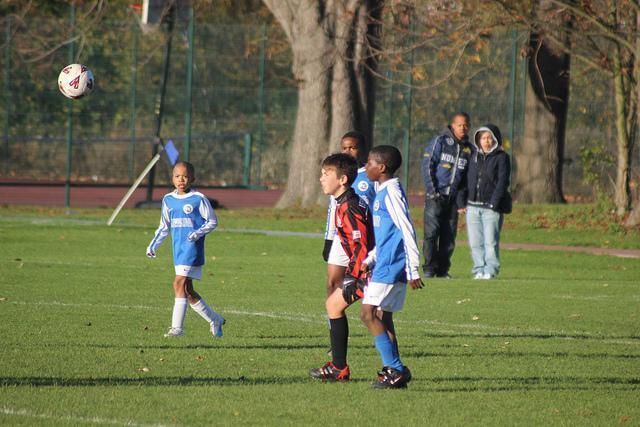How many people are playing?
Give a very brief answer. 4. How many children wear blue and white uniforms?
Give a very brief answer. 3. How many boys are shown?
Give a very brief answer. 4. How many people are in the photo?
Give a very brief answer. 6. 